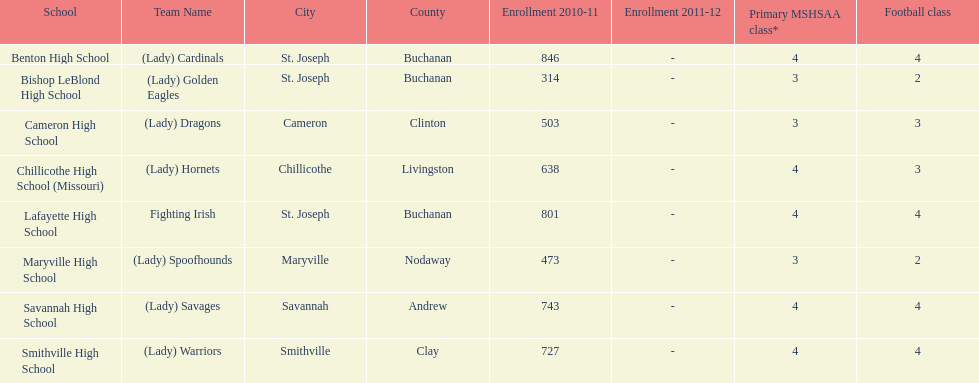What is the number of football classes lafayette high school has? 4. 